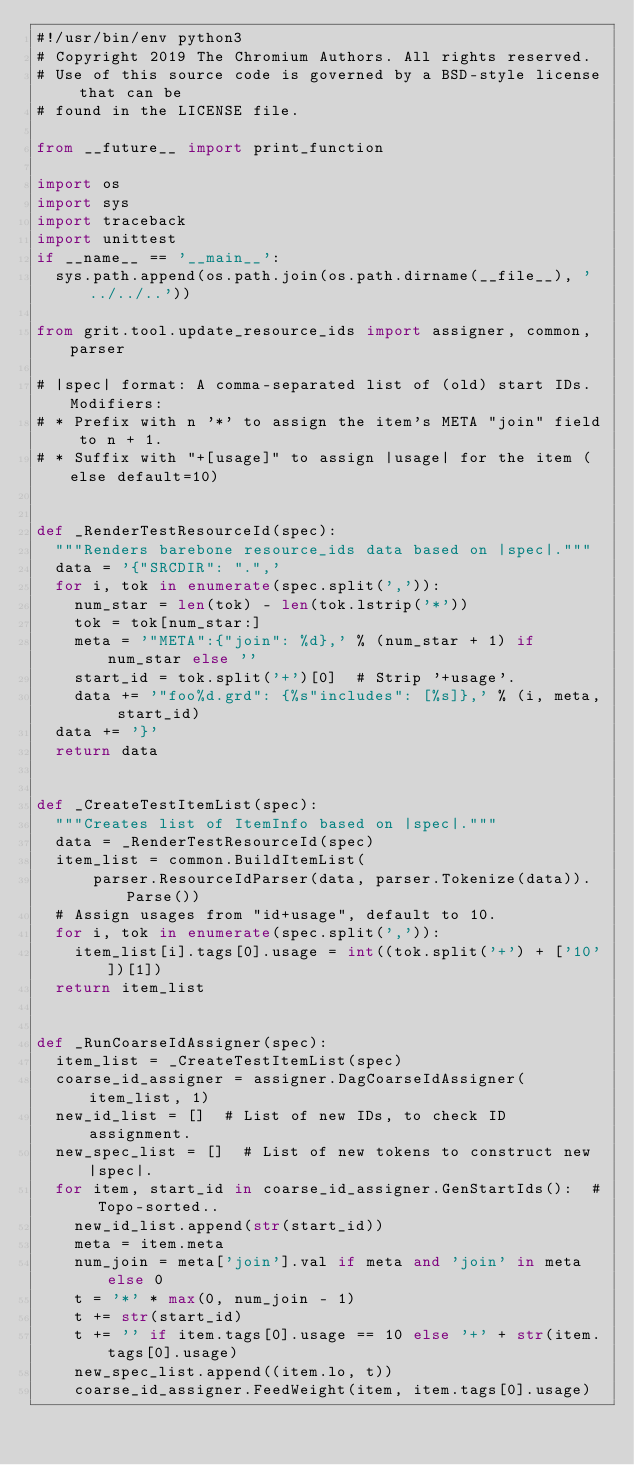<code> <loc_0><loc_0><loc_500><loc_500><_Python_>#!/usr/bin/env python3
# Copyright 2019 The Chromium Authors. All rights reserved.
# Use of this source code is governed by a BSD-style license that can be
# found in the LICENSE file.

from __future__ import print_function

import os
import sys
import traceback
import unittest
if __name__ == '__main__':
  sys.path.append(os.path.join(os.path.dirname(__file__), '../../..'))

from grit.tool.update_resource_ids import assigner, common, parser

# |spec| format: A comma-separated list of (old) start IDs. Modifiers:
# * Prefix with n '*' to assign the item's META "join" field to n + 1.
# * Suffix with "+[usage]" to assign |usage| for the item (else default=10)


def _RenderTestResourceId(spec):
  """Renders barebone resource_ids data based on |spec|."""
  data = '{"SRCDIR": ".",'
  for i, tok in enumerate(spec.split(',')):
    num_star = len(tok) - len(tok.lstrip('*'))
    tok = tok[num_star:]
    meta = '"META":{"join": %d},' % (num_star + 1) if num_star else ''
    start_id = tok.split('+')[0]  # Strip '+usage'.
    data += '"foo%d.grd": {%s"includes": [%s]},' % (i, meta, start_id)
  data += '}'
  return data


def _CreateTestItemList(spec):
  """Creates list of ItemInfo based on |spec|."""
  data = _RenderTestResourceId(spec)
  item_list = common.BuildItemList(
      parser.ResourceIdParser(data, parser.Tokenize(data)).Parse())
  # Assign usages from "id+usage", default to 10.
  for i, tok in enumerate(spec.split(',')):
    item_list[i].tags[0].usage = int((tok.split('+') + ['10'])[1])
  return item_list


def _RunCoarseIdAssigner(spec):
  item_list = _CreateTestItemList(spec)
  coarse_id_assigner = assigner.DagCoarseIdAssigner(item_list, 1)
  new_id_list = []  # List of new IDs, to check ID assignment.
  new_spec_list = []  # List of new tokens to construct new |spec|.
  for item, start_id in coarse_id_assigner.GenStartIds():  # Topo-sorted..
    new_id_list.append(str(start_id))
    meta = item.meta
    num_join = meta['join'].val if meta and 'join' in meta else 0
    t = '*' * max(0, num_join - 1)
    t += str(start_id)
    t += '' if item.tags[0].usage == 10 else '+' + str(item.tags[0].usage)
    new_spec_list.append((item.lo, t))
    coarse_id_assigner.FeedWeight(item, item.tags[0].usage)</code> 